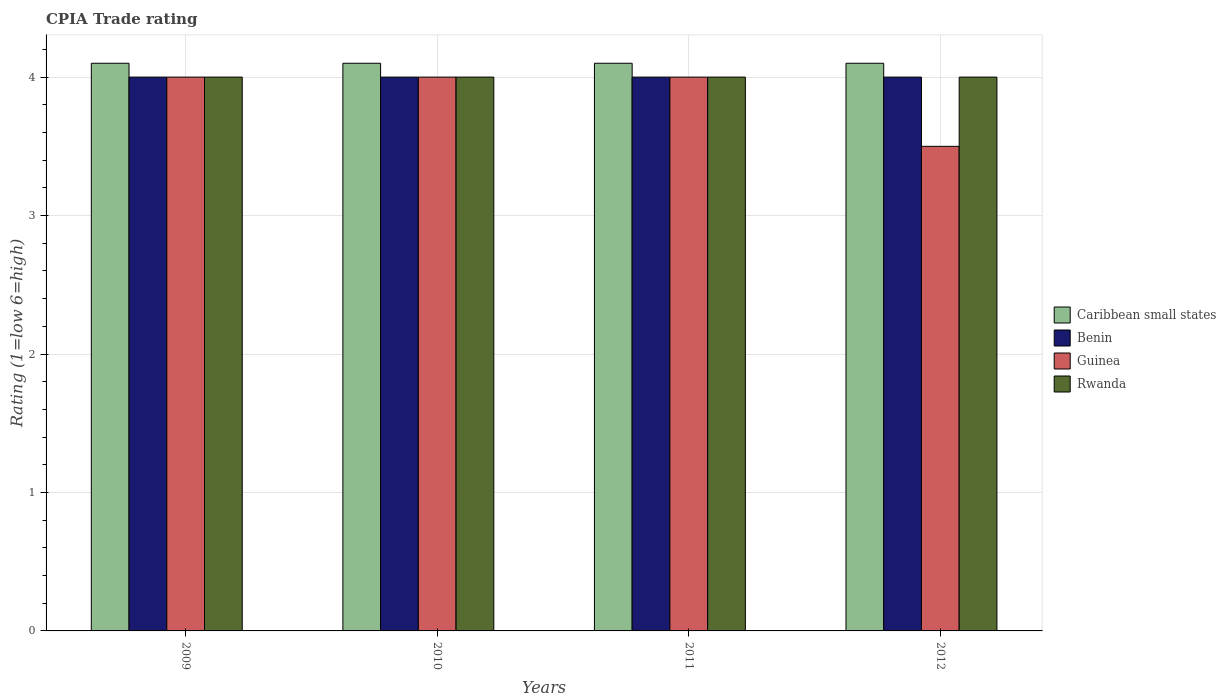How many different coloured bars are there?
Make the answer very short. 4. How many bars are there on the 1st tick from the left?
Your response must be concise. 4. What is the label of the 1st group of bars from the left?
Provide a succinct answer. 2009. In how many cases, is the number of bars for a given year not equal to the number of legend labels?
Give a very brief answer. 0. Across all years, what is the maximum CPIA rating in Guinea?
Keep it short and to the point. 4. Across all years, what is the minimum CPIA rating in Caribbean small states?
Keep it short and to the point. 4.1. In the year 2010, what is the difference between the CPIA rating in Guinea and CPIA rating in Caribbean small states?
Provide a succinct answer. -0.1. In how many years, is the CPIA rating in Rwanda greater than 1.2?
Offer a terse response. 4. What is the ratio of the CPIA rating in Rwanda in 2009 to that in 2010?
Provide a succinct answer. 1. Is the difference between the CPIA rating in Guinea in 2009 and 2011 greater than the difference between the CPIA rating in Caribbean small states in 2009 and 2011?
Ensure brevity in your answer.  No. What is the difference between the highest and the second highest CPIA rating in Caribbean small states?
Provide a succinct answer. 0. In how many years, is the CPIA rating in Rwanda greater than the average CPIA rating in Rwanda taken over all years?
Offer a very short reply. 0. Is it the case that in every year, the sum of the CPIA rating in Guinea and CPIA rating in Benin is greater than the sum of CPIA rating in Caribbean small states and CPIA rating in Rwanda?
Give a very brief answer. No. What does the 4th bar from the left in 2010 represents?
Give a very brief answer. Rwanda. What does the 1st bar from the right in 2009 represents?
Your response must be concise. Rwanda. What is the difference between two consecutive major ticks on the Y-axis?
Give a very brief answer. 1. Does the graph contain any zero values?
Give a very brief answer. No. How many legend labels are there?
Give a very brief answer. 4. How are the legend labels stacked?
Your response must be concise. Vertical. What is the title of the graph?
Ensure brevity in your answer.  CPIA Trade rating. What is the Rating (1=low 6=high) of Caribbean small states in 2009?
Give a very brief answer. 4.1. What is the Rating (1=low 6=high) in Guinea in 2009?
Offer a terse response. 4. What is the Rating (1=low 6=high) in Rwanda in 2009?
Make the answer very short. 4. What is the Rating (1=low 6=high) in Caribbean small states in 2010?
Offer a very short reply. 4.1. What is the Rating (1=low 6=high) of Benin in 2010?
Give a very brief answer. 4. What is the Rating (1=low 6=high) in Rwanda in 2010?
Give a very brief answer. 4. What is the Rating (1=low 6=high) of Benin in 2011?
Your answer should be very brief. 4. What is the Rating (1=low 6=high) in Rwanda in 2011?
Ensure brevity in your answer.  4. What is the Rating (1=low 6=high) in Caribbean small states in 2012?
Provide a succinct answer. 4.1. Across all years, what is the maximum Rating (1=low 6=high) of Caribbean small states?
Keep it short and to the point. 4.1. Across all years, what is the maximum Rating (1=low 6=high) of Benin?
Give a very brief answer. 4. Across all years, what is the maximum Rating (1=low 6=high) of Guinea?
Keep it short and to the point. 4. What is the total Rating (1=low 6=high) of Caribbean small states in the graph?
Your answer should be compact. 16.4. What is the total Rating (1=low 6=high) of Guinea in the graph?
Make the answer very short. 15.5. What is the difference between the Rating (1=low 6=high) in Benin in 2009 and that in 2010?
Make the answer very short. 0. What is the difference between the Rating (1=low 6=high) in Guinea in 2009 and that in 2010?
Offer a terse response. 0. What is the difference between the Rating (1=low 6=high) in Rwanda in 2009 and that in 2010?
Your answer should be very brief. 0. What is the difference between the Rating (1=low 6=high) in Benin in 2009 and that in 2011?
Ensure brevity in your answer.  0. What is the difference between the Rating (1=low 6=high) in Caribbean small states in 2009 and that in 2012?
Your answer should be compact. 0. What is the difference between the Rating (1=low 6=high) of Guinea in 2009 and that in 2012?
Your answer should be compact. 0.5. What is the difference between the Rating (1=low 6=high) of Benin in 2010 and that in 2011?
Give a very brief answer. 0. What is the difference between the Rating (1=low 6=high) in Rwanda in 2010 and that in 2011?
Your response must be concise. 0. What is the difference between the Rating (1=low 6=high) of Guinea in 2010 and that in 2012?
Offer a terse response. 0.5. What is the difference between the Rating (1=low 6=high) in Rwanda in 2010 and that in 2012?
Provide a short and direct response. 0. What is the difference between the Rating (1=low 6=high) of Rwanda in 2011 and that in 2012?
Your answer should be very brief. 0. What is the difference between the Rating (1=low 6=high) of Caribbean small states in 2009 and the Rating (1=low 6=high) of Benin in 2010?
Keep it short and to the point. 0.1. What is the difference between the Rating (1=low 6=high) in Benin in 2009 and the Rating (1=low 6=high) in Rwanda in 2010?
Offer a terse response. 0. What is the difference between the Rating (1=low 6=high) of Guinea in 2009 and the Rating (1=low 6=high) of Rwanda in 2010?
Keep it short and to the point. 0. What is the difference between the Rating (1=low 6=high) in Benin in 2009 and the Rating (1=low 6=high) in Guinea in 2011?
Provide a short and direct response. 0. What is the difference between the Rating (1=low 6=high) of Caribbean small states in 2009 and the Rating (1=low 6=high) of Guinea in 2012?
Ensure brevity in your answer.  0.6. What is the difference between the Rating (1=low 6=high) of Guinea in 2009 and the Rating (1=low 6=high) of Rwanda in 2012?
Give a very brief answer. 0. What is the difference between the Rating (1=low 6=high) of Caribbean small states in 2010 and the Rating (1=low 6=high) of Benin in 2011?
Offer a very short reply. 0.1. What is the difference between the Rating (1=low 6=high) in Benin in 2010 and the Rating (1=low 6=high) in Rwanda in 2011?
Ensure brevity in your answer.  0. What is the difference between the Rating (1=low 6=high) of Guinea in 2010 and the Rating (1=low 6=high) of Rwanda in 2011?
Provide a short and direct response. 0. What is the difference between the Rating (1=low 6=high) of Caribbean small states in 2011 and the Rating (1=low 6=high) of Guinea in 2012?
Give a very brief answer. 0.6. What is the difference between the Rating (1=low 6=high) of Caribbean small states in 2011 and the Rating (1=low 6=high) of Rwanda in 2012?
Your answer should be very brief. 0.1. What is the difference between the Rating (1=low 6=high) of Guinea in 2011 and the Rating (1=low 6=high) of Rwanda in 2012?
Provide a short and direct response. 0. What is the average Rating (1=low 6=high) in Guinea per year?
Keep it short and to the point. 3.88. What is the average Rating (1=low 6=high) of Rwanda per year?
Ensure brevity in your answer.  4. In the year 2009, what is the difference between the Rating (1=low 6=high) of Benin and Rating (1=low 6=high) of Guinea?
Your answer should be compact. 0. In the year 2009, what is the difference between the Rating (1=low 6=high) in Guinea and Rating (1=low 6=high) in Rwanda?
Make the answer very short. 0. In the year 2010, what is the difference between the Rating (1=low 6=high) in Caribbean small states and Rating (1=low 6=high) in Guinea?
Provide a succinct answer. 0.1. In the year 2010, what is the difference between the Rating (1=low 6=high) in Guinea and Rating (1=low 6=high) in Rwanda?
Make the answer very short. 0. In the year 2011, what is the difference between the Rating (1=low 6=high) of Caribbean small states and Rating (1=low 6=high) of Benin?
Keep it short and to the point. 0.1. In the year 2011, what is the difference between the Rating (1=low 6=high) in Caribbean small states and Rating (1=low 6=high) in Rwanda?
Your response must be concise. 0.1. In the year 2011, what is the difference between the Rating (1=low 6=high) of Benin and Rating (1=low 6=high) of Guinea?
Offer a very short reply. 0. In the year 2011, what is the difference between the Rating (1=low 6=high) in Guinea and Rating (1=low 6=high) in Rwanda?
Your response must be concise. 0. In the year 2012, what is the difference between the Rating (1=low 6=high) in Caribbean small states and Rating (1=low 6=high) in Guinea?
Offer a very short reply. 0.6. In the year 2012, what is the difference between the Rating (1=low 6=high) in Caribbean small states and Rating (1=low 6=high) in Rwanda?
Offer a very short reply. 0.1. In the year 2012, what is the difference between the Rating (1=low 6=high) in Benin and Rating (1=low 6=high) in Guinea?
Your answer should be compact. 0.5. In the year 2012, what is the difference between the Rating (1=low 6=high) in Guinea and Rating (1=low 6=high) in Rwanda?
Make the answer very short. -0.5. What is the ratio of the Rating (1=low 6=high) of Benin in 2009 to that in 2010?
Your response must be concise. 1. What is the ratio of the Rating (1=low 6=high) of Rwanda in 2009 to that in 2010?
Offer a terse response. 1. What is the ratio of the Rating (1=low 6=high) of Rwanda in 2009 to that in 2011?
Ensure brevity in your answer.  1. What is the ratio of the Rating (1=low 6=high) of Guinea in 2009 to that in 2012?
Make the answer very short. 1.14. What is the ratio of the Rating (1=low 6=high) in Rwanda in 2009 to that in 2012?
Provide a succinct answer. 1. What is the ratio of the Rating (1=low 6=high) in Benin in 2010 to that in 2011?
Make the answer very short. 1. What is the ratio of the Rating (1=low 6=high) of Guinea in 2010 to that in 2011?
Offer a very short reply. 1. What is the ratio of the Rating (1=low 6=high) in Rwanda in 2010 to that in 2011?
Offer a very short reply. 1. What is the ratio of the Rating (1=low 6=high) in Benin in 2010 to that in 2012?
Provide a short and direct response. 1. What is the ratio of the Rating (1=low 6=high) of Guinea in 2010 to that in 2012?
Offer a very short reply. 1.14. What is the ratio of the Rating (1=low 6=high) of Rwanda in 2010 to that in 2012?
Provide a succinct answer. 1. What is the ratio of the Rating (1=low 6=high) in Caribbean small states in 2011 to that in 2012?
Provide a succinct answer. 1. What is the ratio of the Rating (1=low 6=high) of Guinea in 2011 to that in 2012?
Your response must be concise. 1.14. What is the difference between the highest and the second highest Rating (1=low 6=high) of Guinea?
Offer a very short reply. 0. What is the difference between the highest and the lowest Rating (1=low 6=high) of Rwanda?
Make the answer very short. 0. 